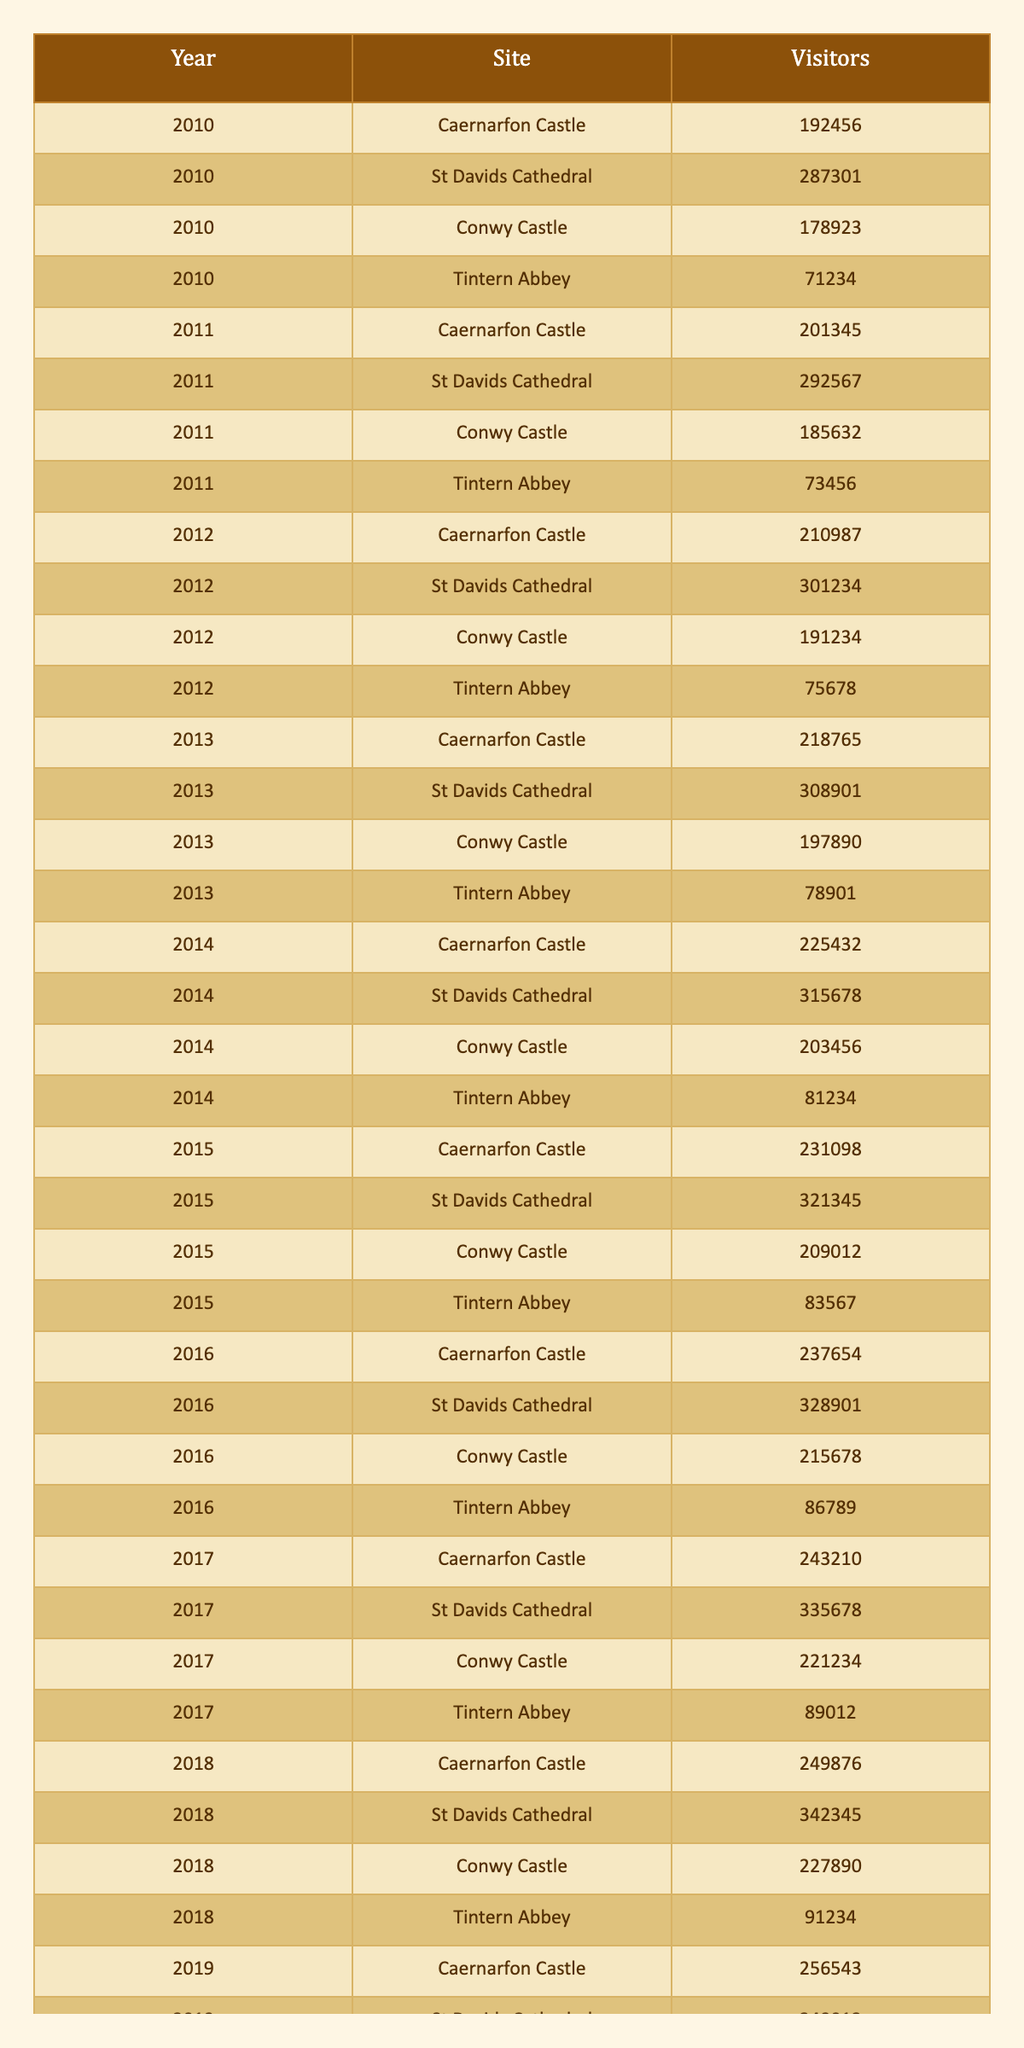What were the total visitors to Caernarfon Castle from 2010 to 2020? To find the total visitors, add the visitors for each year: 192456 + 201345 + 210987 + 218765 + 225432 + 231098 + 237654 + 243210 + 249876 + 256543 = 2294566
Answer: 2294566 Which site had the highest number of visitors in 2019? Referring to the 2019 row, St Davids Cathedral had 349012 visitors, which is higher than the other sites listed for that year.
Answer: St Davids Cathedral What is the average number of visitors to Tintern Abbey over the 11 years? The visitors for Tintern Abbey are: 71234, 73456, 75678, 78901, 81234, 83567, 86789, 89012, 91234, 93456, 37234. Adding these gives 705081, and dividing by 11 gives an average of 64189.182, rounding to 64189.
Answer: 64189 Did the visitor numbers to Conwy Castle increase every year from 2010 to 2019? Checking the visitor numbers each year: 178923, 185632, 191234, 197890, 203456, 209012, 215678, 221234, 227890 shows that each value is higher than the previous one, indicating consistent increases.
Answer: Yes In which year did St Davids Cathedral first exceed 320,000 visitors? Looking at the data for St Davids Cathedral, it first exceeds 320,000 visitors in 2015, with 321345 recorded that year.
Answer: 2015 What is the percentage decrease in visitors to Caernarfon Castle from 2019 to 2020? The number of visitors dropped from 256543 in 2019 to 102345 in 2020. The decrease is 256543 - 102345 = 154198. The percentage decrease is (154198 / 256543) * 100 = 60.2%.
Answer: 60.2% What were the total visitors to Welsh heritage sites in 2014? The total for 2014 is the sum of visitors across all sites: Caernarfon Castle (225432) + St Davids Cathedral (315678) + Conwy Castle (203456) + Tintern Abbey (81234) = 825800.
Answer: 825800 Which site had the fewest visitors in 2020, and what was the number? In 2020, Tintern Abbey had the fewest visitors, with a total of 37234.
Answer: Tintern Abbey, 37234 Was there ever a year in which Caernarfon Castle had fewer visitors than Conwy Castle? Comparing the visitor numbers for both sites from 2010 to 2020 shows that Caernarfon Castle's numbers were always greater than Conwy Castle's throughout these years.
Answer: No What was the trend in visitor numbers for St Davids Cathedral from 2010 to 2020? Analyzing the visitor numbers over the years shows a consistent increase each year, peaking in 2019 at 349012. This indicates a positive upward trend for St Davids Cathedral.
Answer: Increasing 